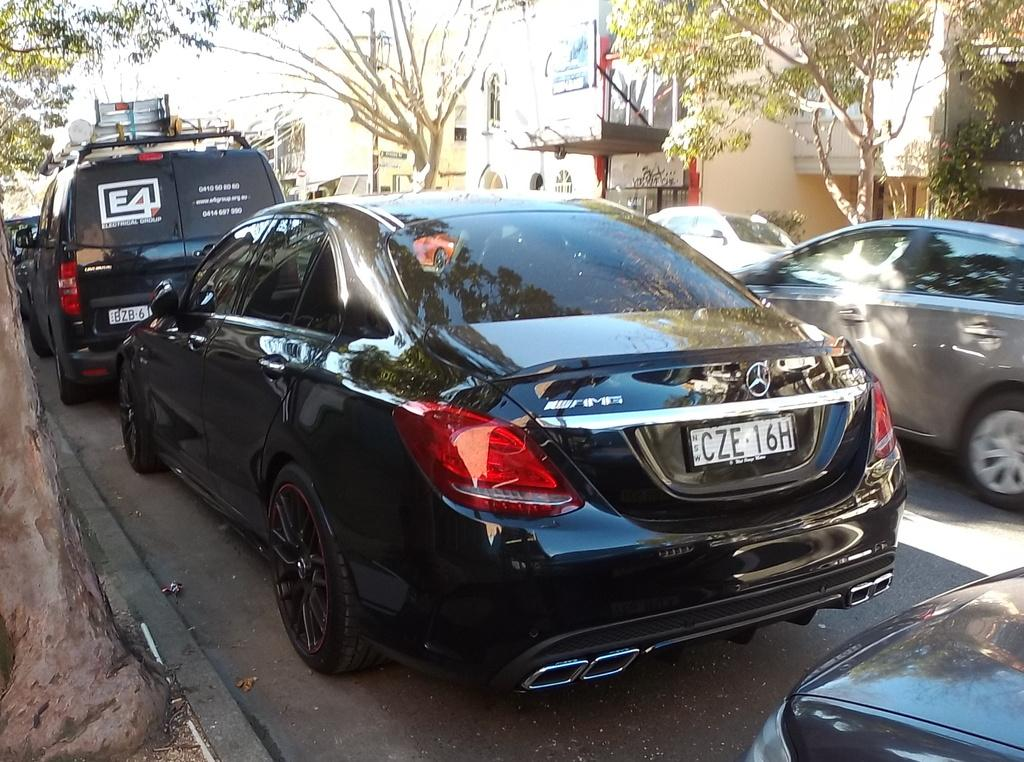What is present on the road in the image? There are vehicles on the road in the image. What can be seen behind the vehicles? There are trees behind the vehicles in the image. What is located behind the trees? There are buildings behind the trees in the image. What type of zinc can be seen on the hill in the image? There is no zinc or hill present in the image. How many tomatoes are growing on the trees in the image? There are no tomatoes or trees with tomatoes in the image. 